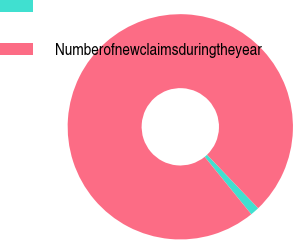Convert chart. <chart><loc_0><loc_0><loc_500><loc_500><pie_chart><ecel><fcel>Numberofnewclaimsduringtheyear<nl><fcel>1.3%<fcel>98.7%<nl></chart> 